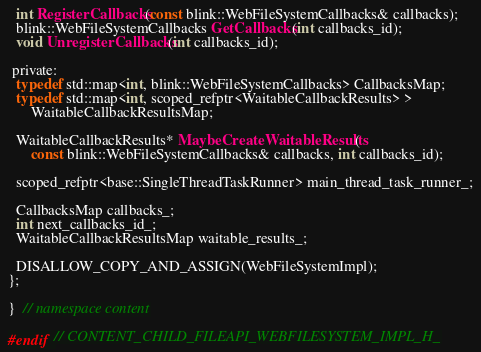<code> <loc_0><loc_0><loc_500><loc_500><_C_>
  int RegisterCallbacks(const blink::WebFileSystemCallbacks& callbacks);
  blink::WebFileSystemCallbacks GetCallbacks(int callbacks_id);
  void UnregisterCallbacks(int callbacks_id);

 private:
  typedef std::map<int, blink::WebFileSystemCallbacks> CallbacksMap;
  typedef std::map<int, scoped_refptr<WaitableCallbackResults> >
      WaitableCallbackResultsMap;

  WaitableCallbackResults* MaybeCreateWaitableResults(
      const blink::WebFileSystemCallbacks& callbacks, int callbacks_id);

  scoped_refptr<base::SingleThreadTaskRunner> main_thread_task_runner_;

  CallbacksMap callbacks_;
  int next_callbacks_id_;
  WaitableCallbackResultsMap waitable_results_;

  DISALLOW_COPY_AND_ASSIGN(WebFileSystemImpl);
};

}  // namespace content

#endif  // CONTENT_CHILD_FILEAPI_WEBFILESYSTEM_IMPL_H_
</code> 